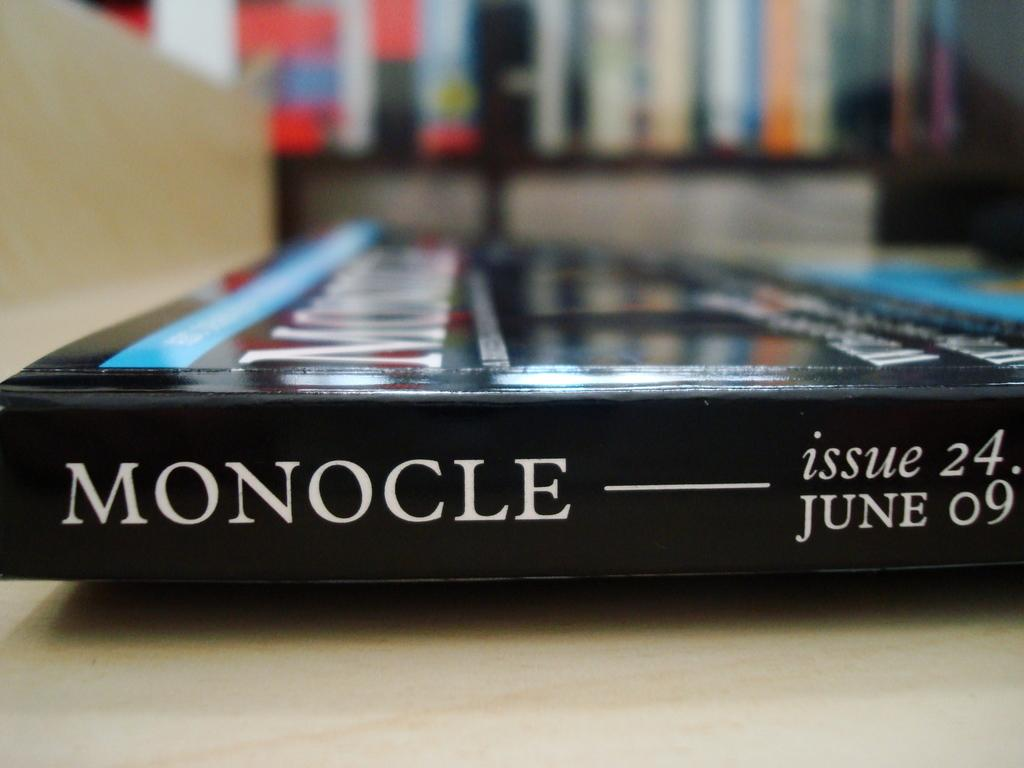Provide a one-sentence caption for the provided image. Issue 24 of Monocle lies on a table unopened. 